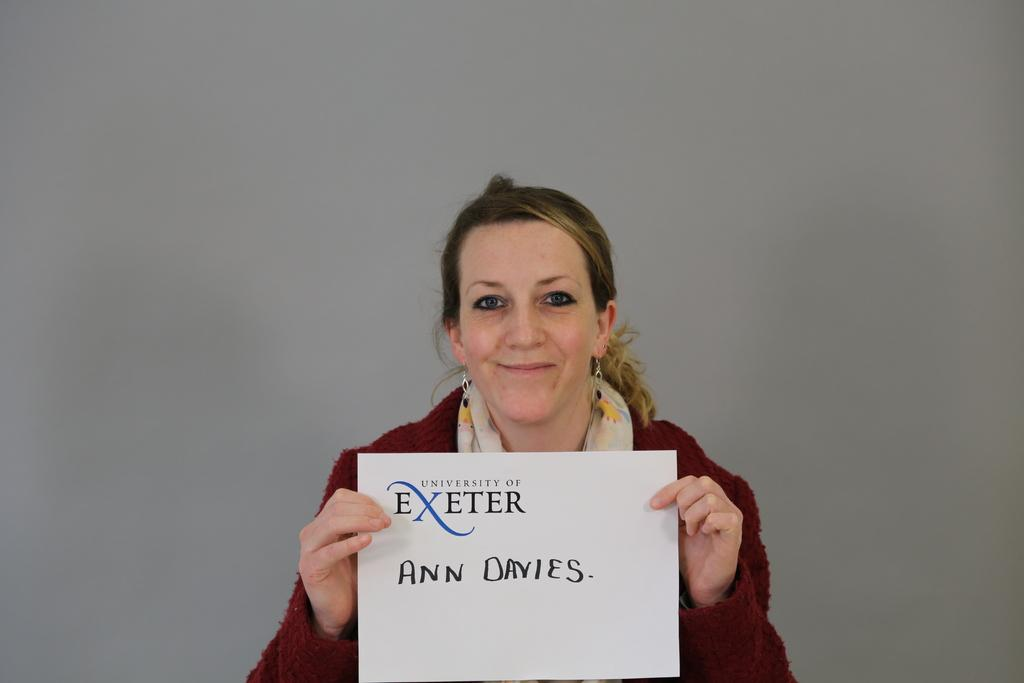What is the woman in the image holding? The woman is holding a paper. Can you describe what is visible on the paper? There is text visible on the paper. What shape is the cup filled with cream in the image? There is no cup filled with cream present in the image. 